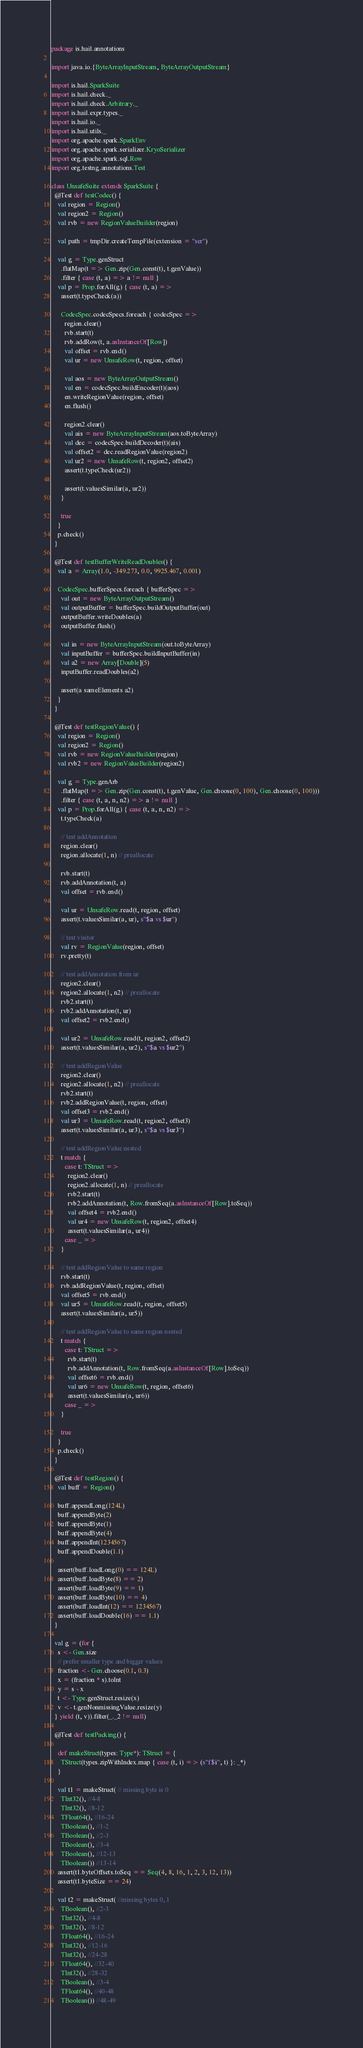Convert code to text. <code><loc_0><loc_0><loc_500><loc_500><_Scala_>package is.hail.annotations

import java.io.{ByteArrayInputStream, ByteArrayOutputStream}

import is.hail.SparkSuite
import is.hail.check._
import is.hail.check.Arbitrary._
import is.hail.expr.types._
import is.hail.io._
import is.hail.utils._
import org.apache.spark.SparkEnv
import org.apache.spark.serializer.KryoSerializer
import org.apache.spark.sql.Row
import org.testng.annotations.Test

class UnsafeSuite extends SparkSuite {
  @Test def testCodec() {
    val region = Region()
    val region2 = Region()
    val rvb = new RegionValueBuilder(region)

    val path = tmpDir.createTempFile(extension = "ser")

    val g = Type.genStruct
      .flatMap(t => Gen.zip(Gen.const(t), t.genValue))
      .filter { case (t, a) => a != null }
    val p = Prop.forAll(g) { case (t, a) =>
      assert(t.typeCheck(a))

      CodecSpec.codecSpecs.foreach { codecSpec =>
        region.clear()
        rvb.start(t)
        rvb.addRow(t, a.asInstanceOf[Row])
        val offset = rvb.end()
        val ur = new UnsafeRow(t, region, offset)

        val aos = new ByteArrayOutputStream()
        val en = codecSpec.buildEncoder(t)(aos)
        en.writeRegionValue(region, offset)
        en.flush()

        region2.clear()
        val ais = new ByteArrayInputStream(aos.toByteArray)
        val dec = codecSpec.buildDecoder(t)(ais)
        val offset2 = dec.readRegionValue(region2)
        val ur2 = new UnsafeRow(t, region2, offset2)
        assert(t.typeCheck(ur2))

        assert(t.valuesSimilar(a, ur2))
      }

      true
    }
    p.check()
  }

  @Test def testBufferWriteReadDoubles() {
    val a = Array(1.0, -349.273, 0.0, 9925.467, 0.001)

    CodecSpec.bufferSpecs.foreach { bufferSpec =>
      val out = new ByteArrayOutputStream()
      val outputBuffer = bufferSpec.buildOutputBuffer(out)
      outputBuffer.writeDoubles(a)
      outputBuffer.flush()

      val in = new ByteArrayInputStream(out.toByteArray)
      val inputBuffer = bufferSpec.buildInputBuffer(in)
      val a2 = new Array[Double](5)
      inputBuffer.readDoubles(a2)

      assert(a sameElements a2)
    }
  }

  @Test def testRegionValue() {
    val region = Region()
    val region2 = Region()
    val rvb = new RegionValueBuilder(region)
    val rvb2 = new RegionValueBuilder(region2)

    val g = Type.genArb
      .flatMap(t => Gen.zip(Gen.const(t), t.genValue, Gen.choose(0, 100), Gen.choose(0, 100)))
      .filter { case (t, a, n, n2) => a != null }
    val p = Prop.forAll(g) { case (t, a, n, n2) =>
      t.typeCheck(a)

      // test addAnnotation
      region.clear()
      region.allocate(1, n) // preallocate

      rvb.start(t)
      rvb.addAnnotation(t, a)
      val offset = rvb.end()

      val ur = UnsafeRow.read(t, region, offset)
      assert(t.valuesSimilar(a, ur), s"$a vs $ur")

      // test visitor
      val rv = RegionValue(region, offset)
      rv.pretty(t)

      // test addAnnotation from ur
      region2.clear()
      region2.allocate(1, n2) // preallocate
      rvb2.start(t)
      rvb2.addAnnotation(t, ur)
      val offset2 = rvb2.end()

      val ur2 = UnsafeRow.read(t, region2, offset2)
      assert(t.valuesSimilar(a, ur2), s"$a vs $ur2")

      // test addRegionValue
      region2.clear()
      region2.allocate(1, n2) // preallocate
      rvb2.start(t)
      rvb2.addRegionValue(t, region, offset)
      val offset3 = rvb2.end()
      val ur3 = UnsafeRow.read(t, region2, offset3)
      assert(t.valuesSimilar(a, ur3), s"$a vs $ur3")

      // test addRegionValue nested
      t match {
        case t: TStruct =>
          region2.clear()
          region2.allocate(1, n) // preallocate
          rvb2.start(t)
          rvb2.addAnnotation(t, Row.fromSeq(a.asInstanceOf[Row].toSeq))
          val offset4 = rvb2.end()
          val ur4 = new UnsafeRow(t, region2, offset4)
          assert(t.valuesSimilar(a, ur4))
        case _ =>
      }

      // test addRegionValue to same region
      rvb.start(t)
      rvb.addRegionValue(t, region, offset)
      val offset5 = rvb.end()
      val ur5 = UnsafeRow.read(t, region, offset5)
      assert(t.valuesSimilar(a, ur5))

      // test addRegionValue to same region nested
      t match {
        case t: TStruct =>
          rvb.start(t)
          rvb.addAnnotation(t, Row.fromSeq(a.asInstanceOf[Row].toSeq))
          val offset6 = rvb.end()
          val ur6 = new UnsafeRow(t, region, offset6)
          assert(t.valuesSimilar(a, ur6))
        case _ =>
      }

      true
    }
    p.check()
  }

  @Test def testRegion() {
    val buff = Region()

    buff.appendLong(124L)
    buff.appendByte(2)
    buff.appendByte(1)
    buff.appendByte(4)
    buff.appendInt(1234567)
    buff.appendDouble(1.1)

    assert(buff.loadLong(0) == 124L)
    assert(buff.loadByte(8) == 2)
    assert(buff.loadByte(9) == 1)
    assert(buff.loadByte(10) == 4)
    assert(buff.loadInt(12) == 1234567)
    assert(buff.loadDouble(16) == 1.1)
  }

  val g = (for {
    s <- Gen.size
    // prefer smaller type and bigger values
    fraction <- Gen.choose(0.1, 0.3)
    x = (fraction * s).toInt
    y = s - x
    t <- Type.genStruct.resize(x)
    v <- t.genNonmissingValue.resize(y)
  } yield (t, v)).filter(_._2 != null)

  @Test def testPacking() {

    def makeStruct(types: Type*): TStruct = {
      TStruct(types.zipWithIndex.map { case (t, i) => (s"f$i", t) }: _*)
    }

    val t1 = makeStruct( // missing byte is 0
      TInt32(), //4-8
      TInt32(), //8-12
      TFloat64(), //16-24
      TBoolean(), //1-2
      TBoolean(), //2-3
      TBoolean(), //3-4
      TBoolean(), //12-13
      TBoolean()) //13-14
    assert(t1.byteOffsets.toSeq == Seq(4, 8, 16, 1, 2, 3, 12, 13))
    assert(t1.byteSize == 24)

    val t2 = makeStruct( //missing bytes 0, 1
      TBoolean(), //2-3
      TInt32(), //4-8
      TInt32(), //8-12
      TFloat64(), //16-24
      TInt32(), //12-16
      TInt32(), //24-28
      TFloat64(), //32-40
      TInt32(), //28-32
      TBoolean(), //3-4
      TFloat64(), //40-48
      TBoolean()) //48-49
</code> 